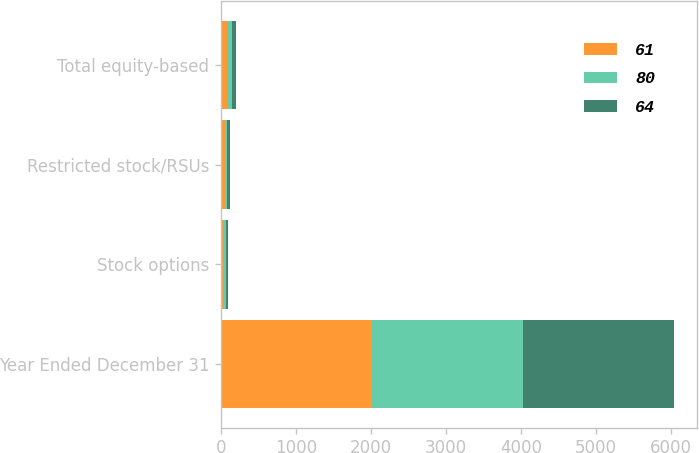<chart> <loc_0><loc_0><loc_500><loc_500><stacked_bar_chart><ecel><fcel>Year Ended December 31<fcel>Stock options<fcel>Restricted stock/RSUs<fcel>Total equity-based<nl><fcel>61<fcel>2017<fcel>34<fcel>46<fcel>80<nl><fcel>80<fcel>2016<fcel>25<fcel>36<fcel>61<nl><fcel>64<fcel>2015<fcel>32<fcel>32<fcel>64<nl></chart> 